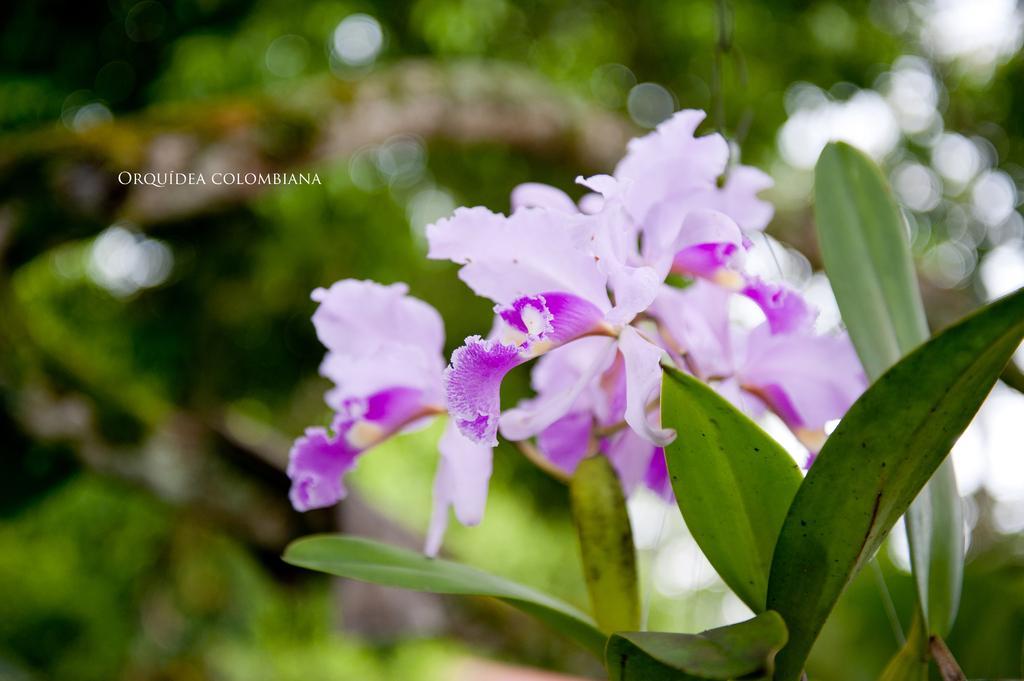Could you give a brief overview of what you see in this image? In this image I can see flowers to the plant. 